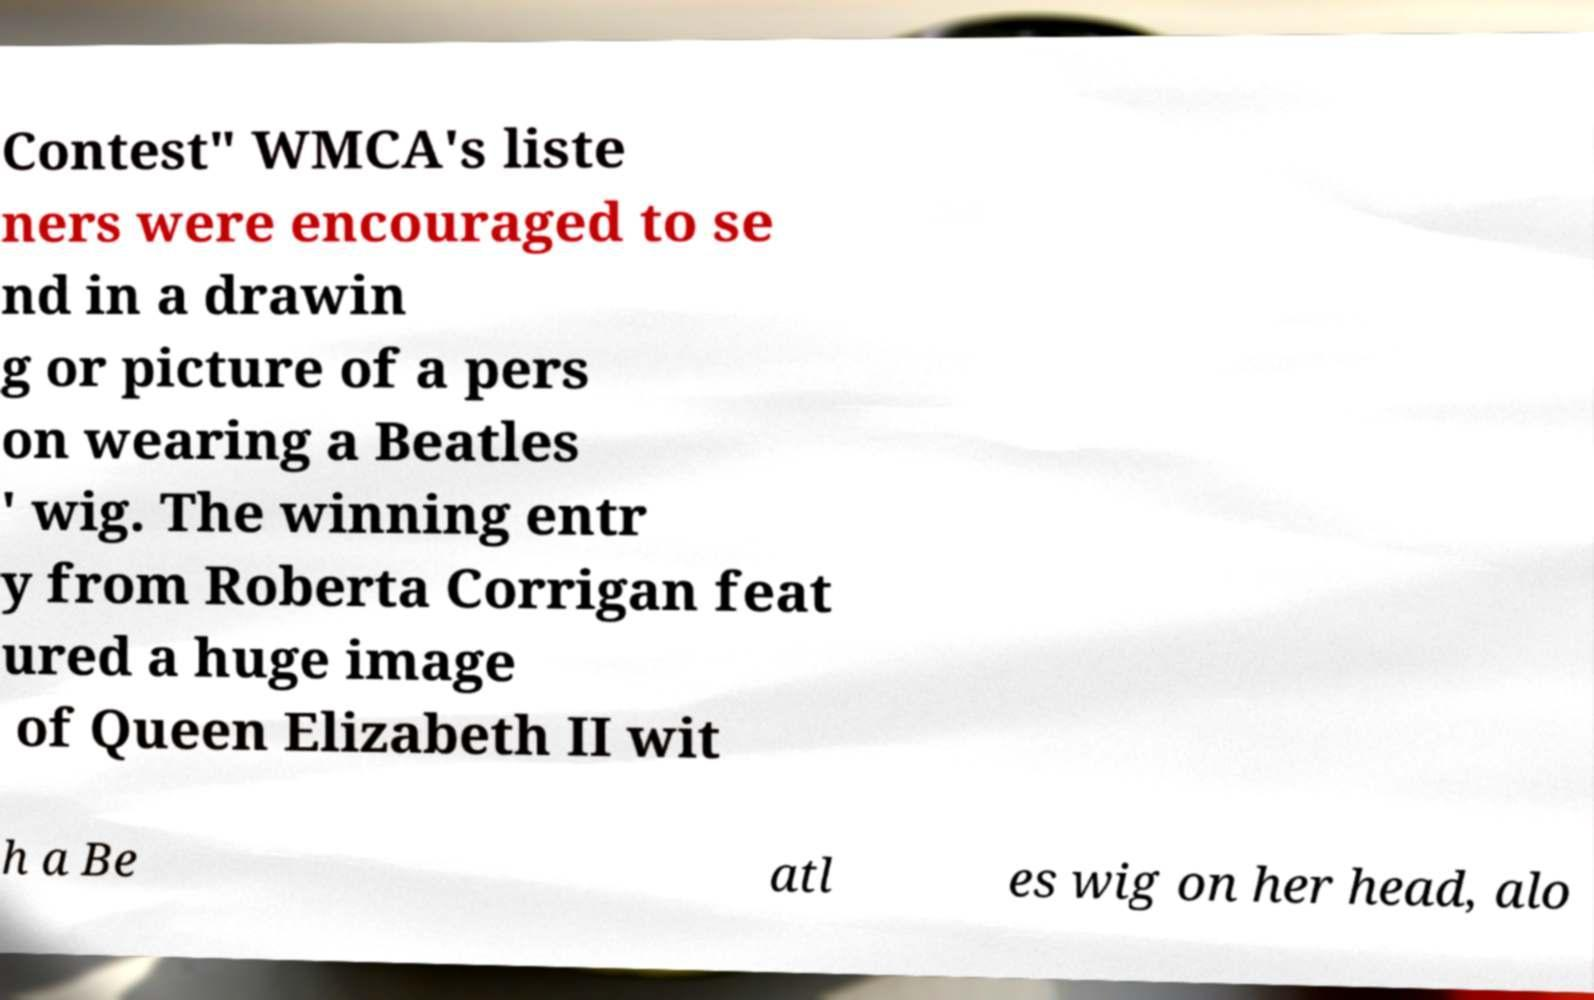There's text embedded in this image that I need extracted. Can you transcribe it verbatim? Contest" WMCA's liste ners were encouraged to se nd in a drawin g or picture of a pers on wearing a Beatles ' wig. The winning entr y from Roberta Corrigan feat ured a huge image of Queen Elizabeth II wit h a Be atl es wig on her head, alo 